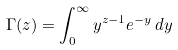<formula> <loc_0><loc_0><loc_500><loc_500>\Gamma ( z ) = \int _ { 0 } ^ { \infty } y ^ { z - 1 } e ^ { - y } \, d y</formula> 